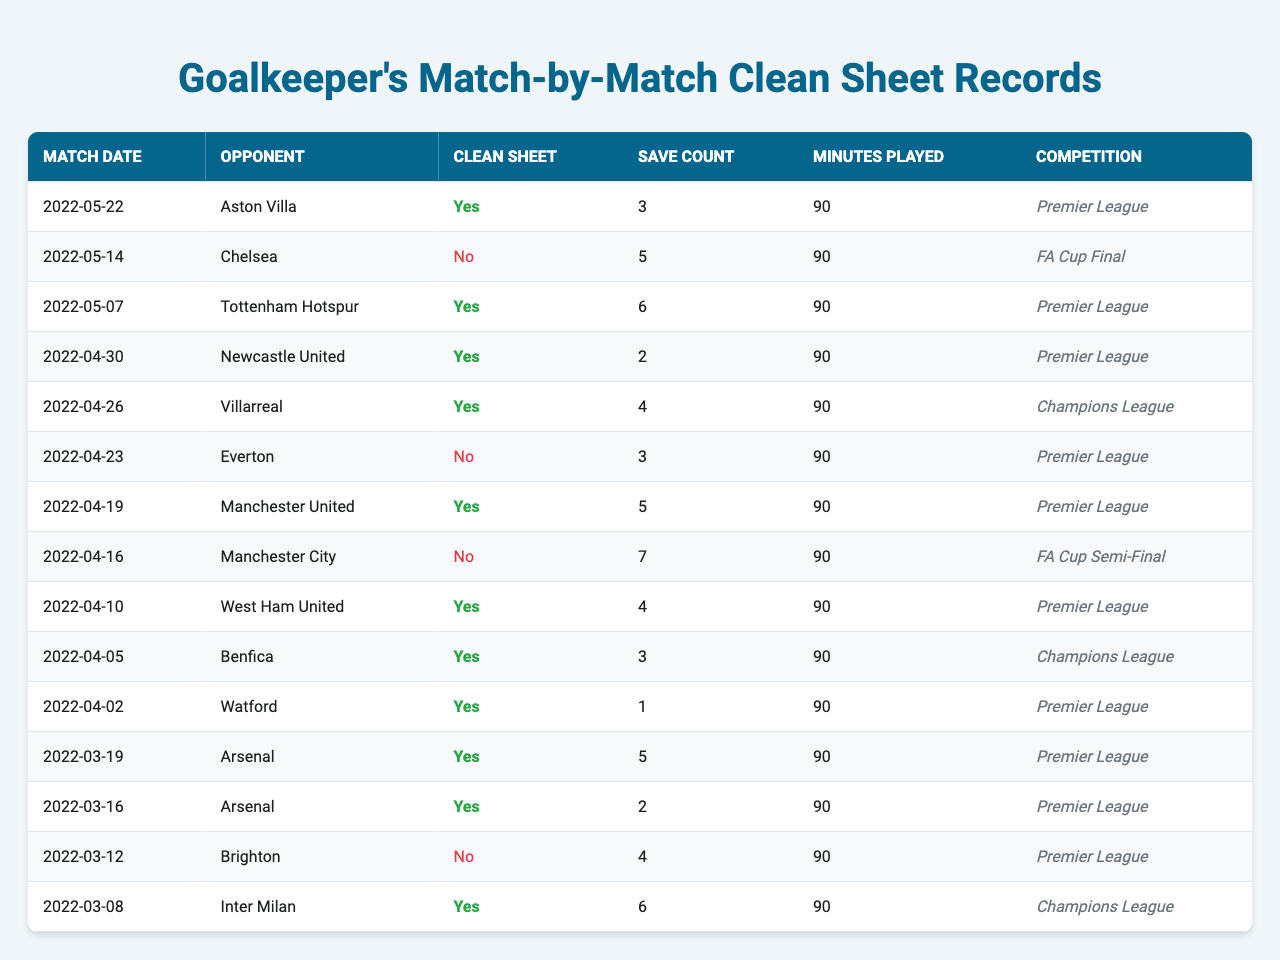What was the total number of clean sheets recorded in the Premier League? There are 8 matches listed in the Premier League, and 5 of them have a clean sheet (marked as "Yes"). These matches occurred on May 22, May 7, April 30, April 19, April 10, April 2, and March 19, March 16. Therefore, the total clean sheets in the Premier League is 5.
Answer: 5 How many saves did the goalkeeper make in the match against Chelsea? The match against Chelsea took place on May 14, and the record shows a save count of 5 for that match. Since the goalkeeper did not keep a clean sheet in this game, the save count remains 5.
Answer: 5 What was the save count in the match where the goalkeeper played for 90 minutes? The goalkeeper played all matches (90 minutes each), but the save count varies by match. The highest save count listed is 7 in the FA Cup Semi-Final against Manchester City on April 16.
Answer: 7 How many matches ended without a clean sheet? There are 4 matches in the table that ended without a clean sheet, identified by "No". Specifically, these matches are against Chelsea, Everton, Manchester City, and Brighton.
Answer: 4 What was the average save count across all matches played? The save counts are 3, 5, 6, 2, 4, 3, 5, 7, 4, 3, 1, 5, 2, 4, and 6, totaling 3+5+6+2+4+3+5+7+4+3+1+5+2+4+6 =  60. There are 15 matches played, so the average save count is 60/15 = 4.
Answer: 4 Was there any match where the goalkeeper achieved a clean sheet with only 1 save? Looking through the records, there is a match against Watford on April 2 where the goalkeeper recorded a clean sheet, but only made 1 save. Therefore, the answer is yes.
Answer: Yes In how many competitions did the goalkeeper achieve a clean sheet? The goalkeeper recorded clean sheets in 4 different competitions: Premier League, FA Cup, and Champions League (as shown in the table). The clean sheets were noted in various matches under these competitions, totaling to 3 for the Premier League and 2 for the Champions League.
Answer: 3 Which opponent did the goalkeeper face in the match that resulted in the lowest save count? The lowest save count is 1 save against Watford on April 2, resulting in a clean sheet. Therefore, the opponent faced in this match is Watford.
Answer: Watford What is the total number of minutes played across all matches with a clean sheet? There are 8 matches with clean sheets, and each match accounts for 90 minutes. Thus, the total minutes played in these clean sheet matches is 8 * 90 = 720 minutes.
Answer: 720 Did the goalkeeper have consecutive clean sheets? Yes, he had consecutive clean sheets in matches against Arsenal on March 19, March 16, Watford on April 2, West Ham on April 10, and Newcastle on April 30, indicating a series of matches with clean sheets.
Answer: Yes 